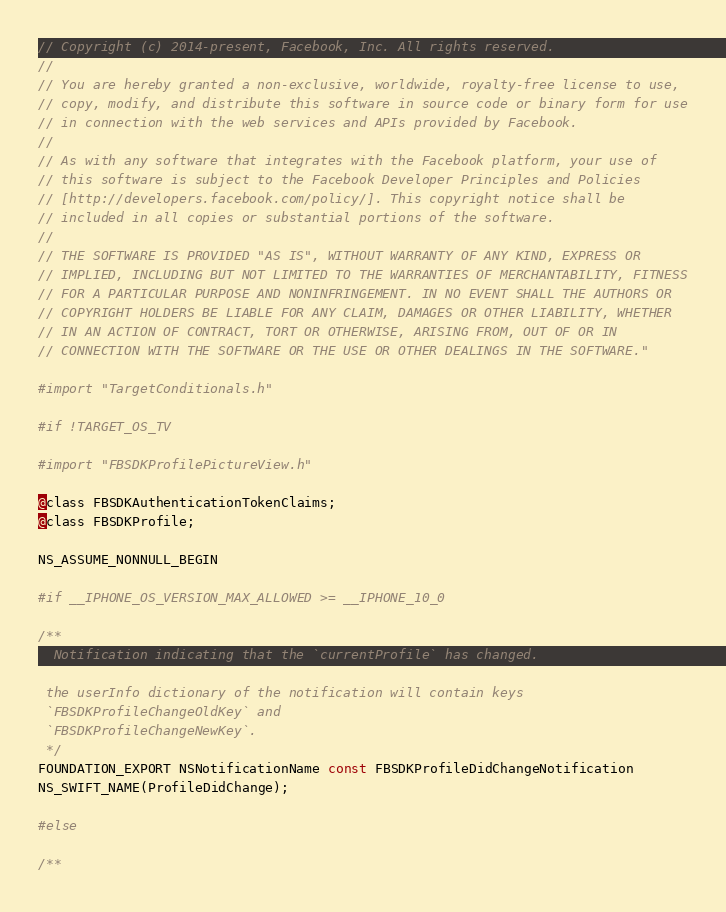<code> <loc_0><loc_0><loc_500><loc_500><_C_>// Copyright (c) 2014-present, Facebook, Inc. All rights reserved.
//
// You are hereby granted a non-exclusive, worldwide, royalty-free license to use,
// copy, modify, and distribute this software in source code or binary form for use
// in connection with the web services and APIs provided by Facebook.
//
// As with any software that integrates with the Facebook platform, your use of
// this software is subject to the Facebook Developer Principles and Policies
// [http://developers.facebook.com/policy/]. This copyright notice shall be
// included in all copies or substantial portions of the software.
//
// THE SOFTWARE IS PROVIDED "AS IS", WITHOUT WARRANTY OF ANY KIND, EXPRESS OR
// IMPLIED, INCLUDING BUT NOT LIMITED TO THE WARRANTIES OF MERCHANTABILITY, FITNESS
// FOR A PARTICULAR PURPOSE AND NONINFRINGEMENT. IN NO EVENT SHALL THE AUTHORS OR
// COPYRIGHT HOLDERS BE LIABLE FOR ANY CLAIM, DAMAGES OR OTHER LIABILITY, WHETHER
// IN AN ACTION OF CONTRACT, TORT OR OTHERWISE, ARISING FROM, OUT OF OR IN
// CONNECTION WITH THE SOFTWARE OR THE USE OR OTHER DEALINGS IN THE SOFTWARE."

#import "TargetConditionals.h"

#if !TARGET_OS_TV

#import "FBSDKProfilePictureView.h"

@class FBSDKAuthenticationTokenClaims;
@class FBSDKProfile;

NS_ASSUME_NONNULL_BEGIN

#if __IPHONE_OS_VERSION_MAX_ALLOWED >= __IPHONE_10_0

/**
  Notification indicating that the `currentProfile` has changed.

 the userInfo dictionary of the notification will contain keys
 `FBSDKProfileChangeOldKey` and
 `FBSDKProfileChangeNewKey`.
 */
FOUNDATION_EXPORT NSNotificationName const FBSDKProfileDidChangeNotification
NS_SWIFT_NAME(ProfileDidChange);

#else

/**</code> 